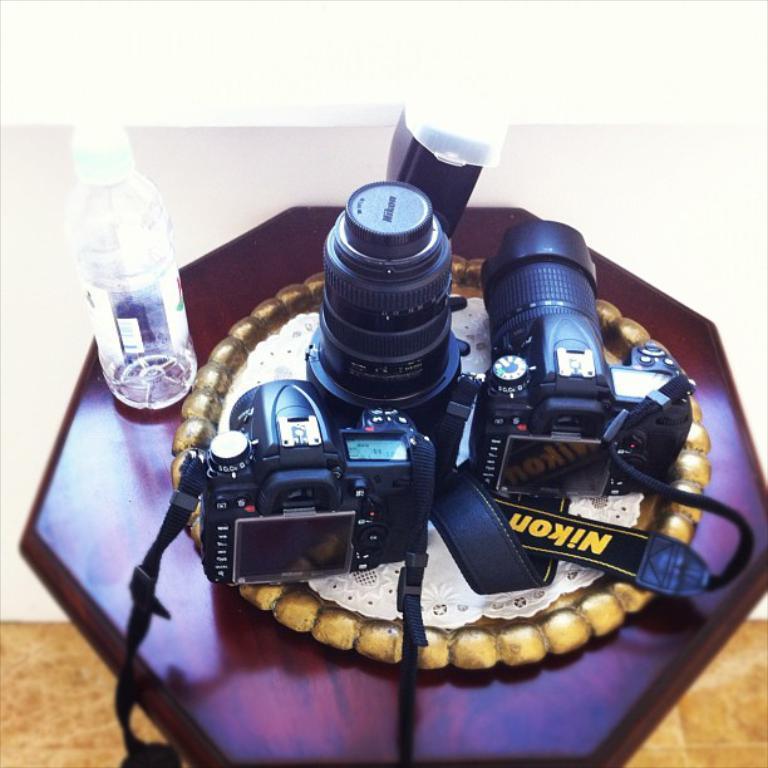Could you give a brief overview of what you see in this image? The picture is taken on table. On table we can see a bottle,camera and plate,cloth. In background there is a white color wall. 